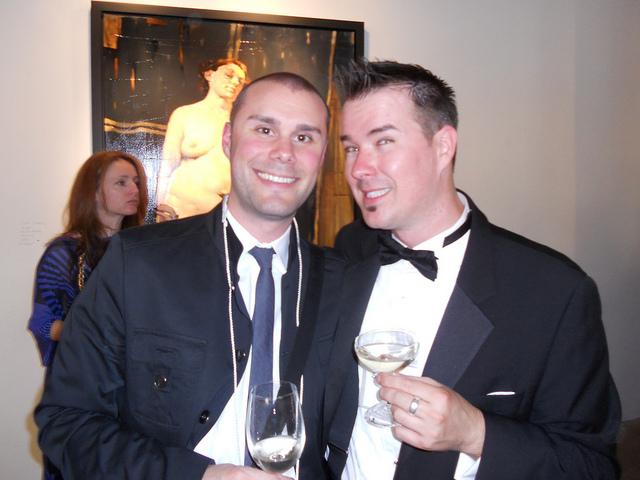From what fruit comes the item being drunk here?

Choices:
A) bananas
B) cherries
C) grapes
D) apples grapes 